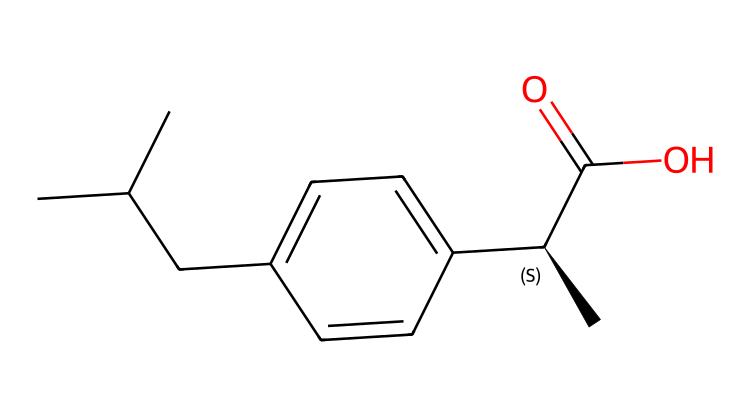What is the molecular formula of ibuprofen? The molecular formula can be derived from the SMILES notation by counting the number of each type of atom present. The SMILES indicates 13 carbon (C) atoms, 18 hydrogen (H) atoms, and 2 oxygen (O) atoms. Thus, the formula is C13H18O2.
Answer: C13H18O2 How many chiral centers are present in ibuprofen? Chiral centers are indicated by the “@” symbol in the SMILES representation, which denotes stereochemistry. In this case, there is one “C@” present, indicating a single chiral center in the structure of ibuprofen.
Answer: one What types of functional groups are present in ibuprofen? Looking at the SMILES representation, there are a carboxylic acid group (-COOH) represented by “C(=O)O” and a phenyl group hinted at by the aromatic ring structure (the "c" characters). This suggests the presence of both a carboxylic acid and an aromatic functional group.
Answer: carboxylic acid and aromatic What is the significance of the chiral center in ibuprofen? The chiral center allows for the existence of enantiomers, which can have different biological effects. In the case of ibuprofen, the specific enantiomer may exhibit the desired therapeutic effects, while the other may not. This is an important aspect of how chiral compounds function in biological systems.
Answer: enantiomers What is the primary role of ibuprofen in medicine? Ibuprofen is primarily used as an analgesic, which is a substance that alleviates pain. Its chemical structure allows it to interfere with the production of certain chemicals in the body that signal pain.
Answer: analgesic What does the “C(=O)O” part of the SMILES represent in terms of chemical functionality? The “C(=O)O” notation indicates a carboxylic acid functional group, which is characterized by a carbon atom double bonded to an oxygen atom and single bonded to a hydroxyl group (-OH). This is significant for ibuprofen's activity and solubility.
Answer: carboxylic acid 